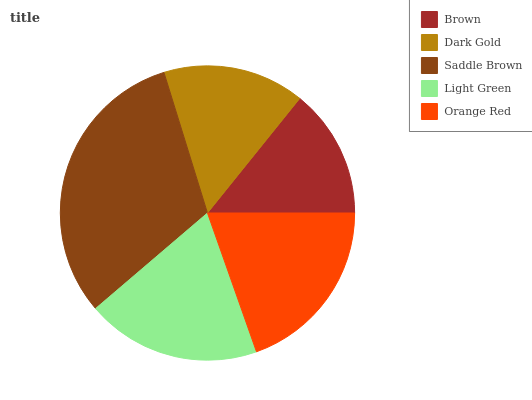Is Brown the minimum?
Answer yes or no. Yes. Is Saddle Brown the maximum?
Answer yes or no. Yes. Is Dark Gold the minimum?
Answer yes or no. No. Is Dark Gold the maximum?
Answer yes or no. No. Is Dark Gold greater than Brown?
Answer yes or no. Yes. Is Brown less than Dark Gold?
Answer yes or no. Yes. Is Brown greater than Dark Gold?
Answer yes or no. No. Is Dark Gold less than Brown?
Answer yes or no. No. Is Light Green the high median?
Answer yes or no. Yes. Is Light Green the low median?
Answer yes or no. Yes. Is Saddle Brown the high median?
Answer yes or no. No. Is Orange Red the low median?
Answer yes or no. No. 